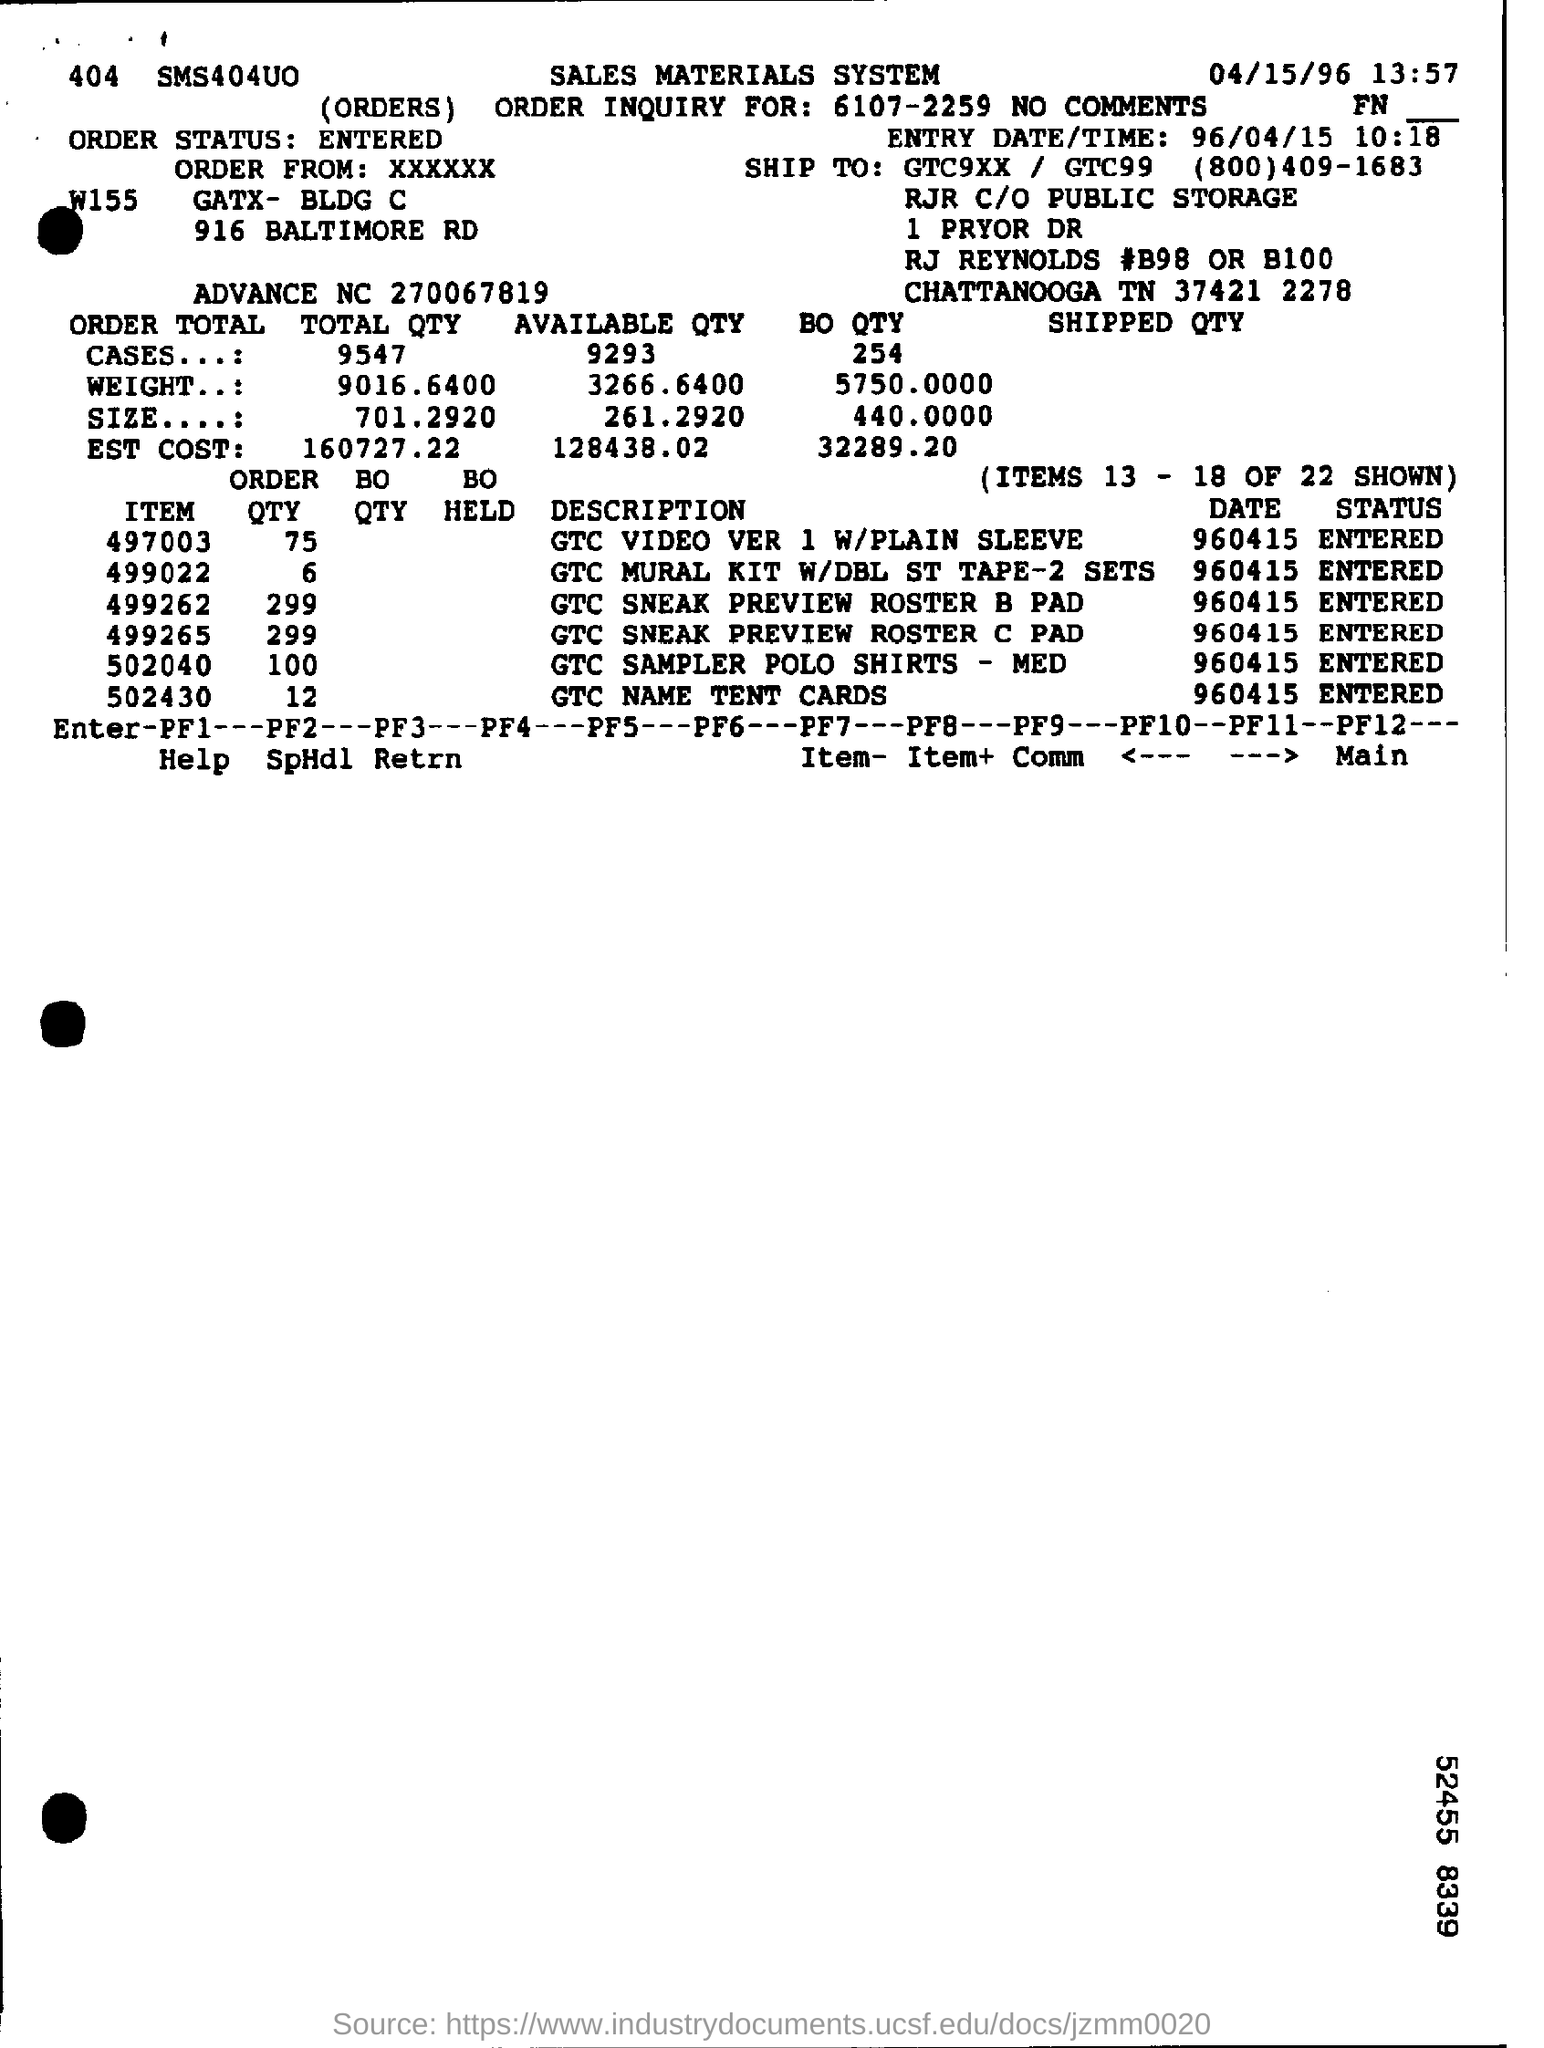Draw attention to some important aspects in this diagram. The estimated cost for the total quantity is 160,727.22. The total quantity is approximately 701.2920. The entry date and time is April 15, 1996 at 10:18 in the morning. What is the estimated cost for available quantity of 128,438.02? The available quantity is 3266.6400... 